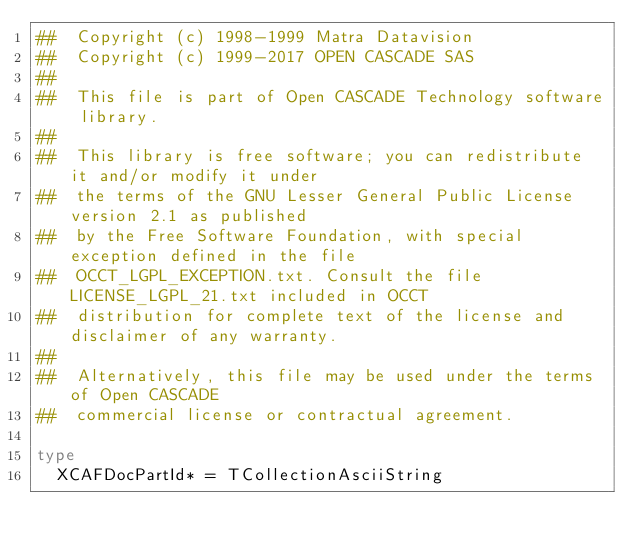<code> <loc_0><loc_0><loc_500><loc_500><_Nim_>##  Copyright (c) 1998-1999 Matra Datavision
##  Copyright (c) 1999-2017 OPEN CASCADE SAS
##
##  This file is part of Open CASCADE Technology software library.
##
##  This library is free software; you can redistribute it and/or modify it under
##  the terms of the GNU Lesser General Public License version 2.1 as published
##  by the Free Software Foundation, with special exception defined in the file
##  OCCT_LGPL_EXCEPTION.txt. Consult the file LICENSE_LGPL_21.txt included in OCCT
##  distribution for complete text of the license and disclaimer of any warranty.
##
##  Alternatively, this file may be used under the terms of Open CASCADE
##  commercial license or contractual agreement.

type
  XCAFDocPartId* = TCollectionAsciiString


























</code> 